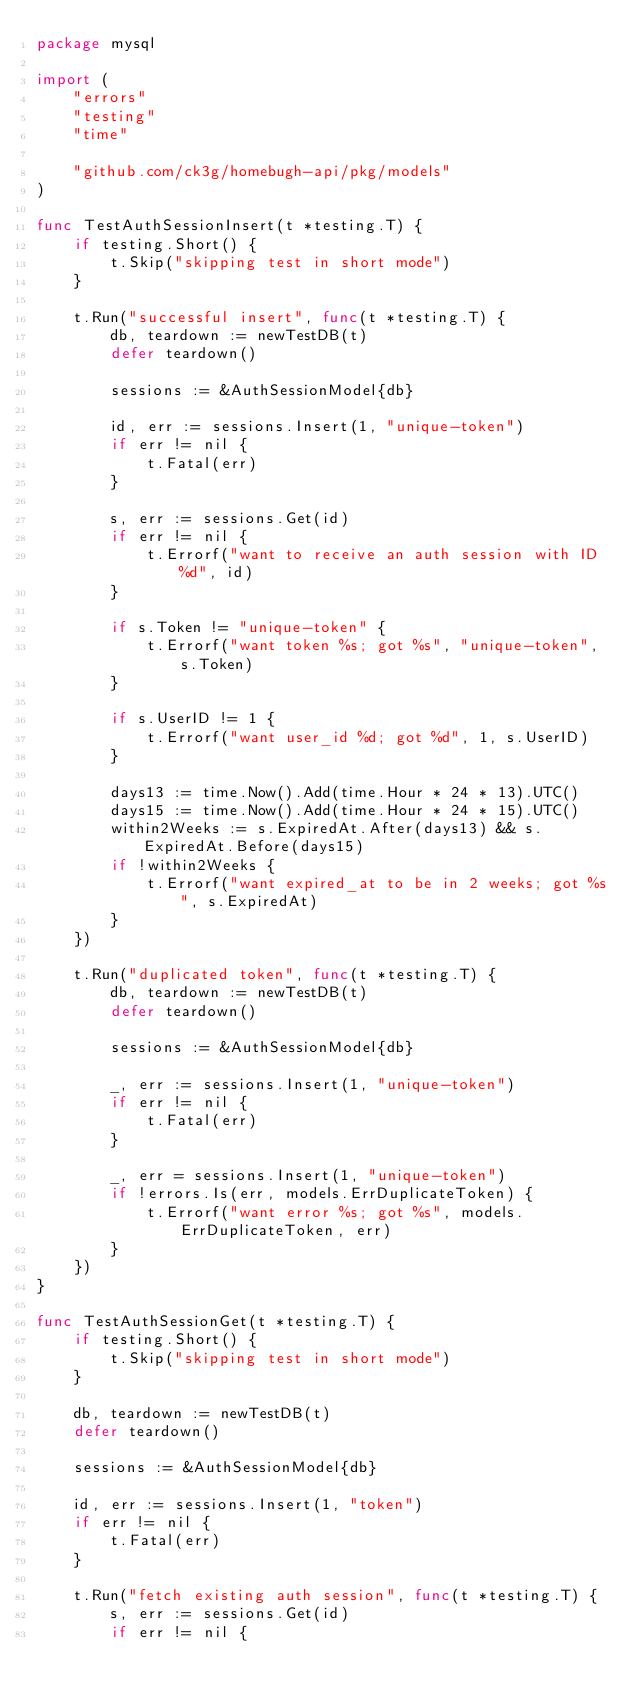Convert code to text. <code><loc_0><loc_0><loc_500><loc_500><_Go_>package mysql

import (
	"errors"
	"testing"
	"time"

	"github.com/ck3g/homebugh-api/pkg/models"
)

func TestAuthSessionInsert(t *testing.T) {
	if testing.Short() {
		t.Skip("skipping test in short mode")
	}

	t.Run("successful insert", func(t *testing.T) {
		db, teardown := newTestDB(t)
		defer teardown()

		sessions := &AuthSessionModel{db}

		id, err := sessions.Insert(1, "unique-token")
		if err != nil {
			t.Fatal(err)
		}

		s, err := sessions.Get(id)
		if err != nil {
			t.Errorf("want to receive an auth session with ID %d", id)
		}

		if s.Token != "unique-token" {
			t.Errorf("want token %s; got %s", "unique-token", s.Token)
		}

		if s.UserID != 1 {
			t.Errorf("want user_id %d; got %d", 1, s.UserID)
		}

		days13 := time.Now().Add(time.Hour * 24 * 13).UTC()
		days15 := time.Now().Add(time.Hour * 24 * 15).UTC()
		within2Weeks := s.ExpiredAt.After(days13) && s.ExpiredAt.Before(days15)
		if !within2Weeks {
			t.Errorf("want expired_at to be in 2 weeks; got %s", s.ExpiredAt)
		}
	})

	t.Run("duplicated token", func(t *testing.T) {
		db, teardown := newTestDB(t)
		defer teardown()

		sessions := &AuthSessionModel{db}

		_, err := sessions.Insert(1, "unique-token")
		if err != nil {
			t.Fatal(err)
		}

		_, err = sessions.Insert(1, "unique-token")
		if !errors.Is(err, models.ErrDuplicateToken) {
			t.Errorf("want error %s; got %s", models.ErrDuplicateToken, err)
		}
	})
}

func TestAuthSessionGet(t *testing.T) {
	if testing.Short() {
		t.Skip("skipping test in short mode")
	}

	db, teardown := newTestDB(t)
	defer teardown()

	sessions := &AuthSessionModel{db}

	id, err := sessions.Insert(1, "token")
	if err != nil {
		t.Fatal(err)
	}

	t.Run("fetch existing auth session", func(t *testing.T) {
		s, err := sessions.Get(id)
		if err != nil {</code> 